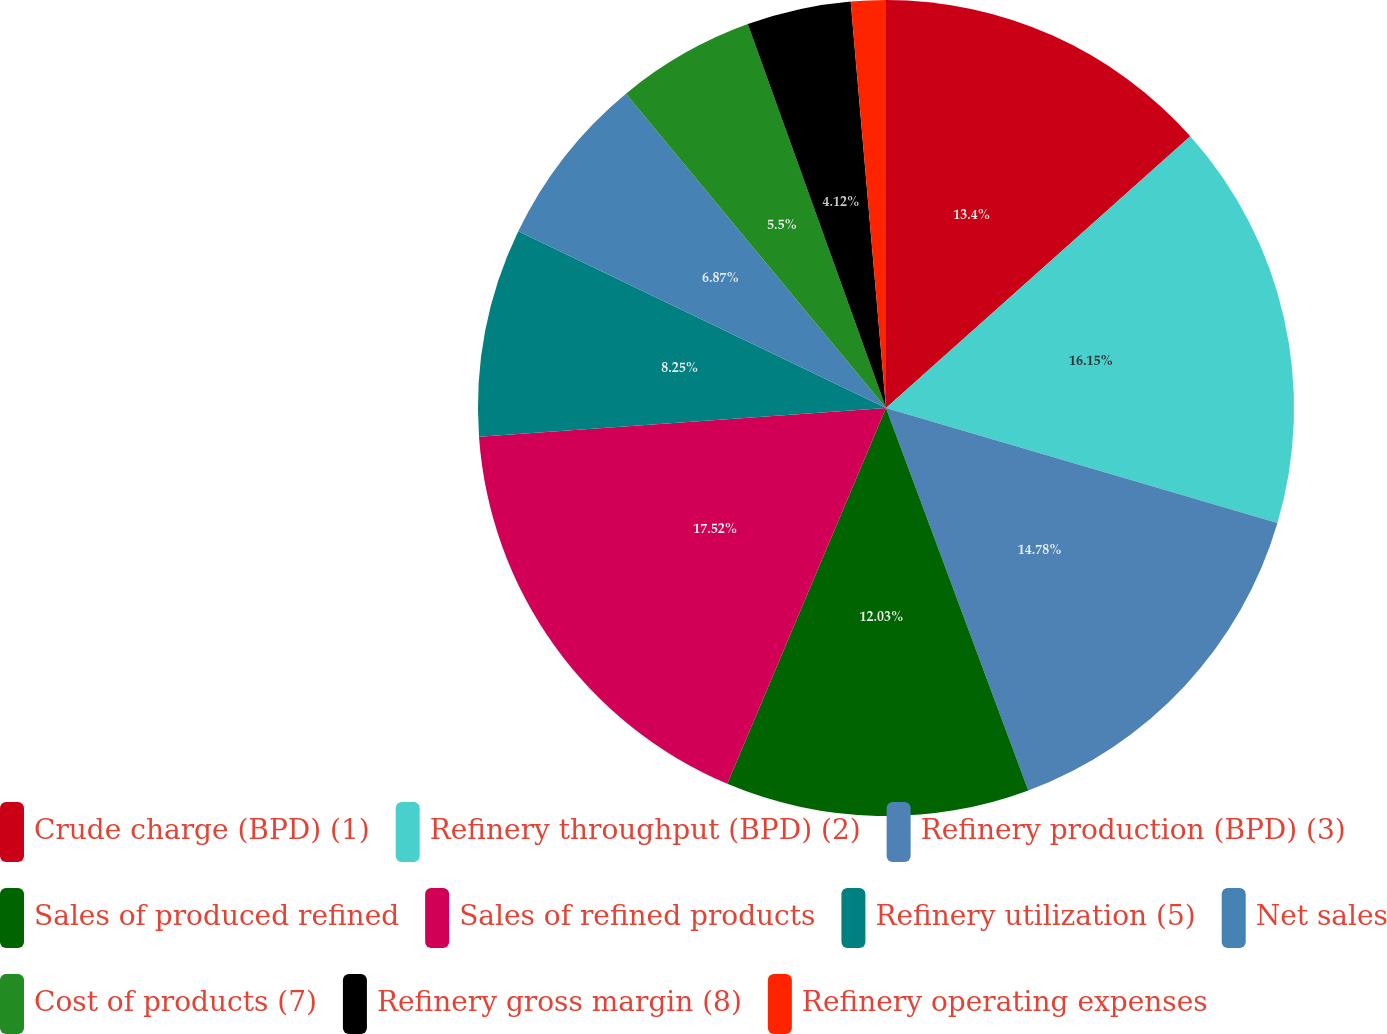<chart> <loc_0><loc_0><loc_500><loc_500><pie_chart><fcel>Crude charge (BPD) (1)<fcel>Refinery throughput (BPD) (2)<fcel>Refinery production (BPD) (3)<fcel>Sales of produced refined<fcel>Sales of refined products<fcel>Refinery utilization (5)<fcel>Net sales<fcel>Cost of products (7)<fcel>Refinery gross margin (8)<fcel>Refinery operating expenses<nl><fcel>13.4%<fcel>16.15%<fcel>14.78%<fcel>12.03%<fcel>17.52%<fcel>8.25%<fcel>6.87%<fcel>5.5%<fcel>4.12%<fcel>1.38%<nl></chart> 